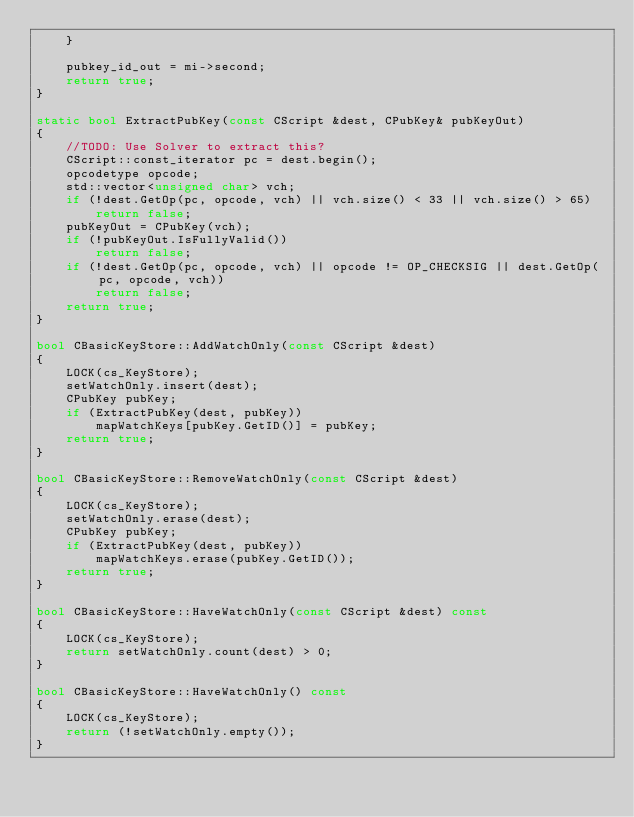<code> <loc_0><loc_0><loc_500><loc_500><_C++_>    }

    pubkey_id_out = mi->second;
    return true;
}

static bool ExtractPubKey(const CScript &dest, CPubKey& pubKeyOut)
{
    //TODO: Use Solver to extract this?
    CScript::const_iterator pc = dest.begin();
    opcodetype opcode;
    std::vector<unsigned char> vch;
    if (!dest.GetOp(pc, opcode, vch) || vch.size() < 33 || vch.size() > 65)
        return false;
    pubKeyOut = CPubKey(vch);
    if (!pubKeyOut.IsFullyValid())
        return false;
    if (!dest.GetOp(pc, opcode, vch) || opcode != OP_CHECKSIG || dest.GetOp(pc, opcode, vch))
        return false;
    return true;
}

bool CBasicKeyStore::AddWatchOnly(const CScript &dest)
{
    LOCK(cs_KeyStore);
    setWatchOnly.insert(dest);
    CPubKey pubKey;
    if (ExtractPubKey(dest, pubKey))
        mapWatchKeys[pubKey.GetID()] = pubKey;
    return true;
}

bool CBasicKeyStore::RemoveWatchOnly(const CScript &dest)
{
    LOCK(cs_KeyStore);
    setWatchOnly.erase(dest);
    CPubKey pubKey;
    if (ExtractPubKey(dest, pubKey))
        mapWatchKeys.erase(pubKey.GetID());
    return true;
}

bool CBasicKeyStore::HaveWatchOnly(const CScript &dest) const
{
    LOCK(cs_KeyStore);
    return setWatchOnly.count(dest) > 0;
}

bool CBasicKeyStore::HaveWatchOnly() const
{
    LOCK(cs_KeyStore);
    return (!setWatchOnly.empty());
}
</code> 